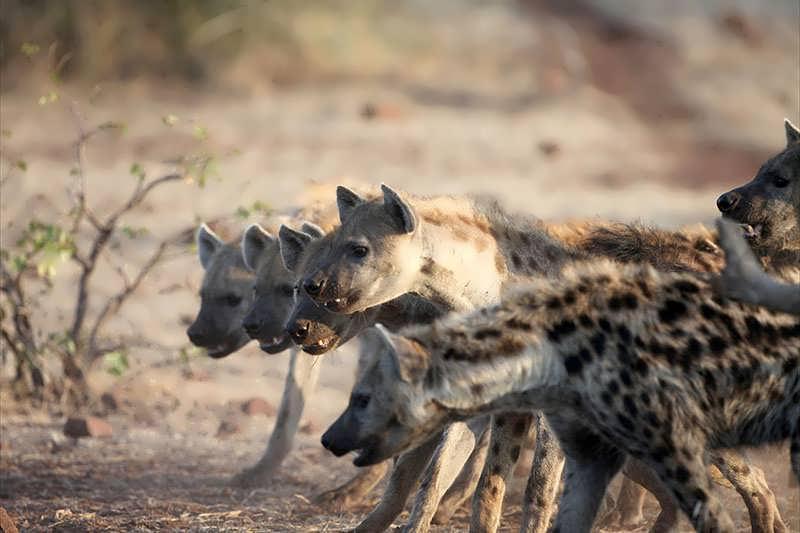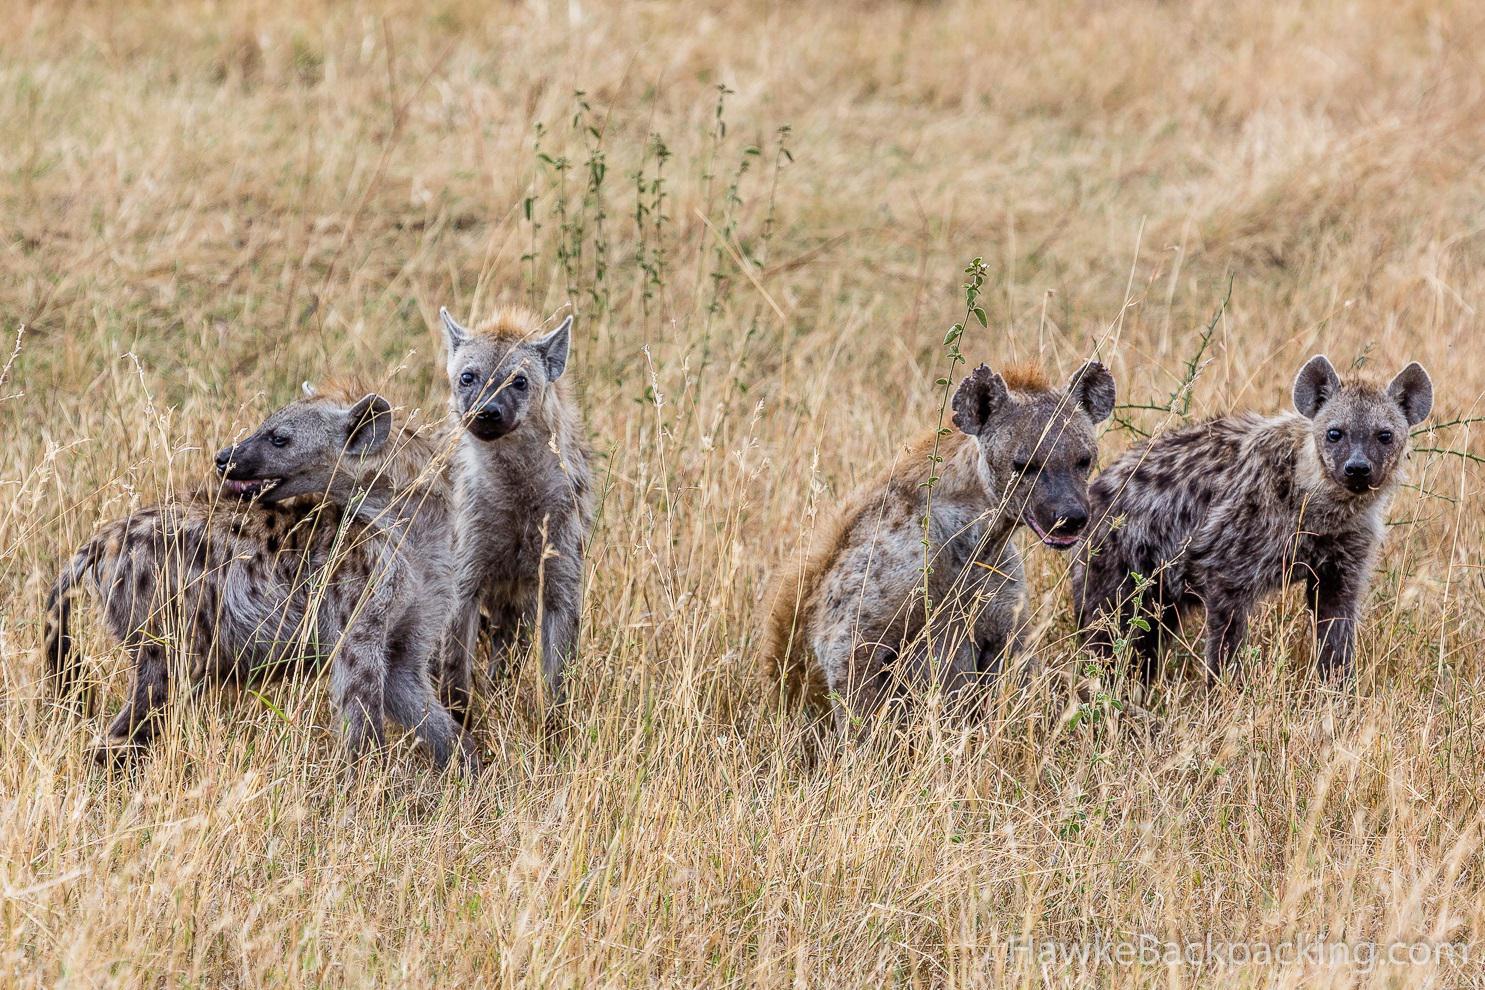The first image is the image on the left, the second image is the image on the right. Given the left and right images, does the statement "Hyenas are attacking a lion." hold true? Answer yes or no. No. The first image is the image on the left, the second image is the image on the right. Assess this claim about the two images: "Multiple hyenas and one open-mouthed lion are engaged in action in one image.". Correct or not? Answer yes or no. No. 